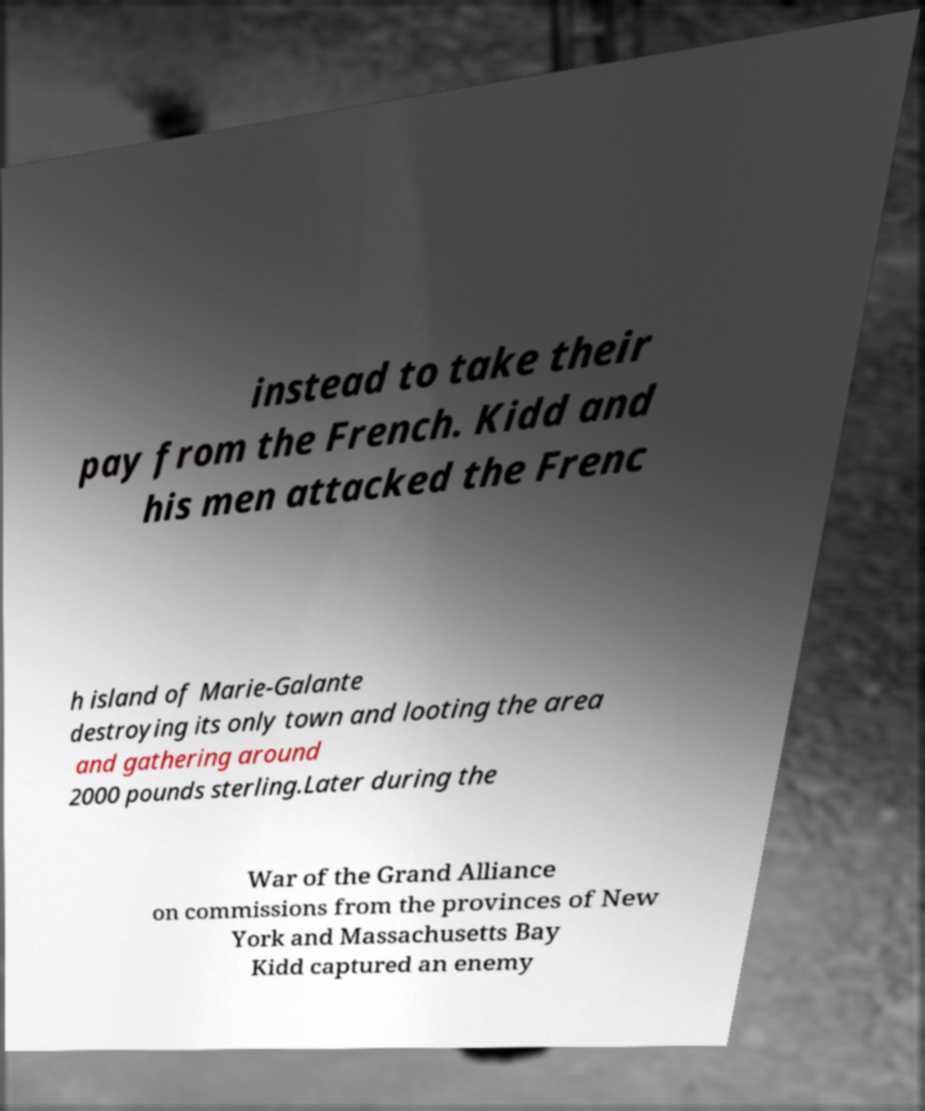What messages or text are displayed in this image? I need them in a readable, typed format. instead to take their pay from the French. Kidd and his men attacked the Frenc h island of Marie-Galante destroying its only town and looting the area and gathering around 2000 pounds sterling.Later during the War of the Grand Alliance on commissions from the provinces of New York and Massachusetts Bay Kidd captured an enemy 